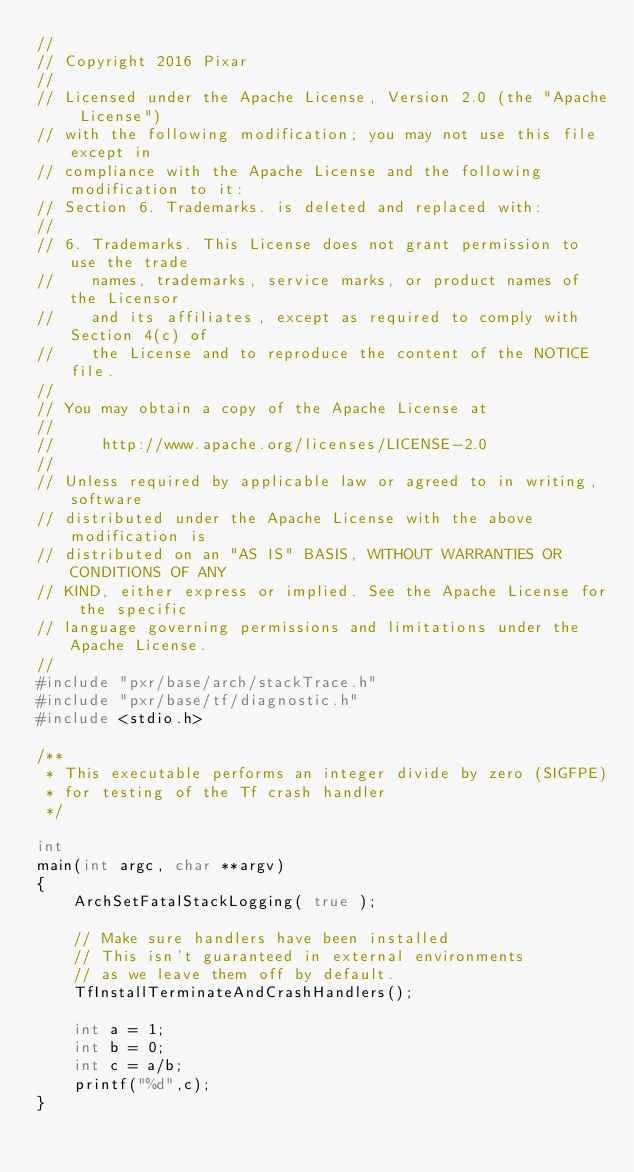<code> <loc_0><loc_0><loc_500><loc_500><_C++_>//
// Copyright 2016 Pixar
//
// Licensed under the Apache License, Version 2.0 (the "Apache License")
// with the following modification; you may not use this file except in
// compliance with the Apache License and the following modification to it:
// Section 6. Trademarks. is deleted and replaced with:
//
// 6. Trademarks. This License does not grant permission to use the trade
//    names, trademarks, service marks, or product names of the Licensor
//    and its affiliates, except as required to comply with Section 4(c) of
//    the License and to reproduce the content of the NOTICE file.
//
// You may obtain a copy of the Apache License at
//
//     http://www.apache.org/licenses/LICENSE-2.0
//
// Unless required by applicable law or agreed to in writing, software
// distributed under the Apache License with the above modification is
// distributed on an "AS IS" BASIS, WITHOUT WARRANTIES OR CONDITIONS OF ANY
// KIND, either express or implied. See the Apache License for the specific
// language governing permissions and limitations under the Apache License.
//
#include "pxr/base/arch/stackTrace.h"
#include "pxr/base/tf/diagnostic.h"
#include <stdio.h>

/**
 * This executable performs an integer divide by zero (SIGFPE)
 * for testing of the Tf crash handler
 */

int
main(int argc, char **argv)
{
    ArchSetFatalStackLogging( true );

    // Make sure handlers have been installed
    // This isn't guaranteed in external environments
    // as we leave them off by default.
    TfInstallTerminateAndCrashHandlers();

    int a = 1;
    int b = 0;
    int c = a/b;
    printf("%d",c);
}


</code> 